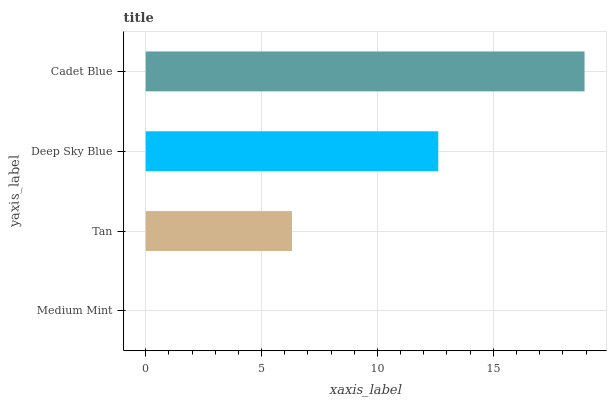Is Medium Mint the minimum?
Answer yes or no. Yes. Is Cadet Blue the maximum?
Answer yes or no. Yes. Is Tan the minimum?
Answer yes or no. No. Is Tan the maximum?
Answer yes or no. No. Is Tan greater than Medium Mint?
Answer yes or no. Yes. Is Medium Mint less than Tan?
Answer yes or no. Yes. Is Medium Mint greater than Tan?
Answer yes or no. No. Is Tan less than Medium Mint?
Answer yes or no. No. Is Deep Sky Blue the high median?
Answer yes or no. Yes. Is Tan the low median?
Answer yes or no. Yes. Is Cadet Blue the high median?
Answer yes or no. No. Is Cadet Blue the low median?
Answer yes or no. No. 